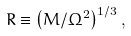<formula> <loc_0><loc_0><loc_500><loc_500>R \equiv \left ( M / \Omega ^ { 2 } \right ) ^ { 1 / 3 } ,</formula> 